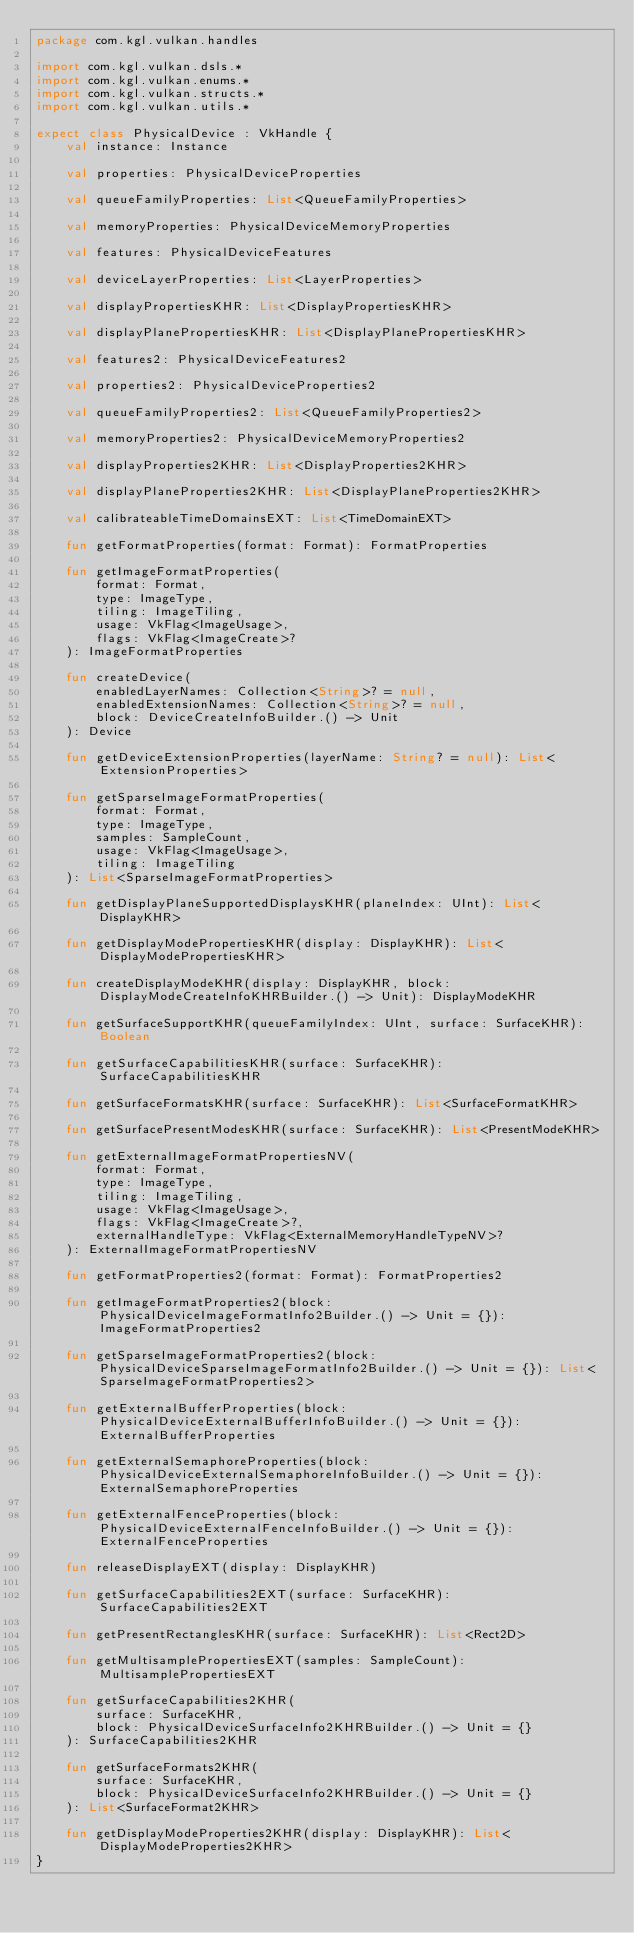Convert code to text. <code><loc_0><loc_0><loc_500><loc_500><_Kotlin_>package com.kgl.vulkan.handles

import com.kgl.vulkan.dsls.*
import com.kgl.vulkan.enums.*
import com.kgl.vulkan.structs.*
import com.kgl.vulkan.utils.*

expect class PhysicalDevice : VkHandle {
	val instance: Instance

	val properties: PhysicalDeviceProperties

	val queueFamilyProperties: List<QueueFamilyProperties>

	val memoryProperties: PhysicalDeviceMemoryProperties

	val features: PhysicalDeviceFeatures

	val deviceLayerProperties: List<LayerProperties>

	val displayPropertiesKHR: List<DisplayPropertiesKHR>

	val displayPlanePropertiesKHR: List<DisplayPlanePropertiesKHR>

	val features2: PhysicalDeviceFeatures2

	val properties2: PhysicalDeviceProperties2

	val queueFamilyProperties2: List<QueueFamilyProperties2>

	val memoryProperties2: PhysicalDeviceMemoryProperties2

	val displayProperties2KHR: List<DisplayProperties2KHR>

	val displayPlaneProperties2KHR: List<DisplayPlaneProperties2KHR>

	val calibrateableTimeDomainsEXT: List<TimeDomainEXT>

	fun getFormatProperties(format: Format): FormatProperties

	fun getImageFormatProperties(
		format: Format,
		type: ImageType,
		tiling: ImageTiling,
		usage: VkFlag<ImageUsage>,
		flags: VkFlag<ImageCreate>?
	): ImageFormatProperties

	fun createDevice(
		enabledLayerNames: Collection<String>? = null,
		enabledExtensionNames: Collection<String>? = null,
		block: DeviceCreateInfoBuilder.() -> Unit
	): Device

	fun getDeviceExtensionProperties(layerName: String? = null): List<ExtensionProperties>

	fun getSparseImageFormatProperties(
		format: Format,
		type: ImageType,
		samples: SampleCount,
		usage: VkFlag<ImageUsage>,
		tiling: ImageTiling
	): List<SparseImageFormatProperties>

	fun getDisplayPlaneSupportedDisplaysKHR(planeIndex: UInt): List<DisplayKHR>

	fun getDisplayModePropertiesKHR(display: DisplayKHR): List<DisplayModePropertiesKHR>

	fun createDisplayModeKHR(display: DisplayKHR, block: DisplayModeCreateInfoKHRBuilder.() -> Unit): DisplayModeKHR

	fun getSurfaceSupportKHR(queueFamilyIndex: UInt, surface: SurfaceKHR): Boolean

	fun getSurfaceCapabilitiesKHR(surface: SurfaceKHR): SurfaceCapabilitiesKHR

	fun getSurfaceFormatsKHR(surface: SurfaceKHR): List<SurfaceFormatKHR>

	fun getSurfacePresentModesKHR(surface: SurfaceKHR): List<PresentModeKHR>

	fun getExternalImageFormatPropertiesNV(
		format: Format,
		type: ImageType,
		tiling: ImageTiling,
		usage: VkFlag<ImageUsage>,
		flags: VkFlag<ImageCreate>?,
		externalHandleType: VkFlag<ExternalMemoryHandleTypeNV>?
	): ExternalImageFormatPropertiesNV

	fun getFormatProperties2(format: Format): FormatProperties2

	fun getImageFormatProperties2(block: PhysicalDeviceImageFormatInfo2Builder.() -> Unit = {}): ImageFormatProperties2

	fun getSparseImageFormatProperties2(block: PhysicalDeviceSparseImageFormatInfo2Builder.() -> Unit = {}): List<SparseImageFormatProperties2>

	fun getExternalBufferProperties(block: PhysicalDeviceExternalBufferInfoBuilder.() -> Unit = {}): ExternalBufferProperties

	fun getExternalSemaphoreProperties(block: PhysicalDeviceExternalSemaphoreInfoBuilder.() -> Unit = {}): ExternalSemaphoreProperties

	fun getExternalFenceProperties(block: PhysicalDeviceExternalFenceInfoBuilder.() -> Unit = {}): ExternalFenceProperties

	fun releaseDisplayEXT(display: DisplayKHR)

	fun getSurfaceCapabilities2EXT(surface: SurfaceKHR): SurfaceCapabilities2EXT

	fun getPresentRectanglesKHR(surface: SurfaceKHR): List<Rect2D>

	fun getMultisamplePropertiesEXT(samples: SampleCount): MultisamplePropertiesEXT

	fun getSurfaceCapabilities2KHR(
		surface: SurfaceKHR,
		block: PhysicalDeviceSurfaceInfo2KHRBuilder.() -> Unit = {}
	): SurfaceCapabilities2KHR

	fun getSurfaceFormats2KHR(
		surface: SurfaceKHR,
		block: PhysicalDeviceSurfaceInfo2KHRBuilder.() -> Unit = {}
	): List<SurfaceFormat2KHR>

	fun getDisplayModeProperties2KHR(display: DisplayKHR): List<DisplayModeProperties2KHR>
}
</code> 